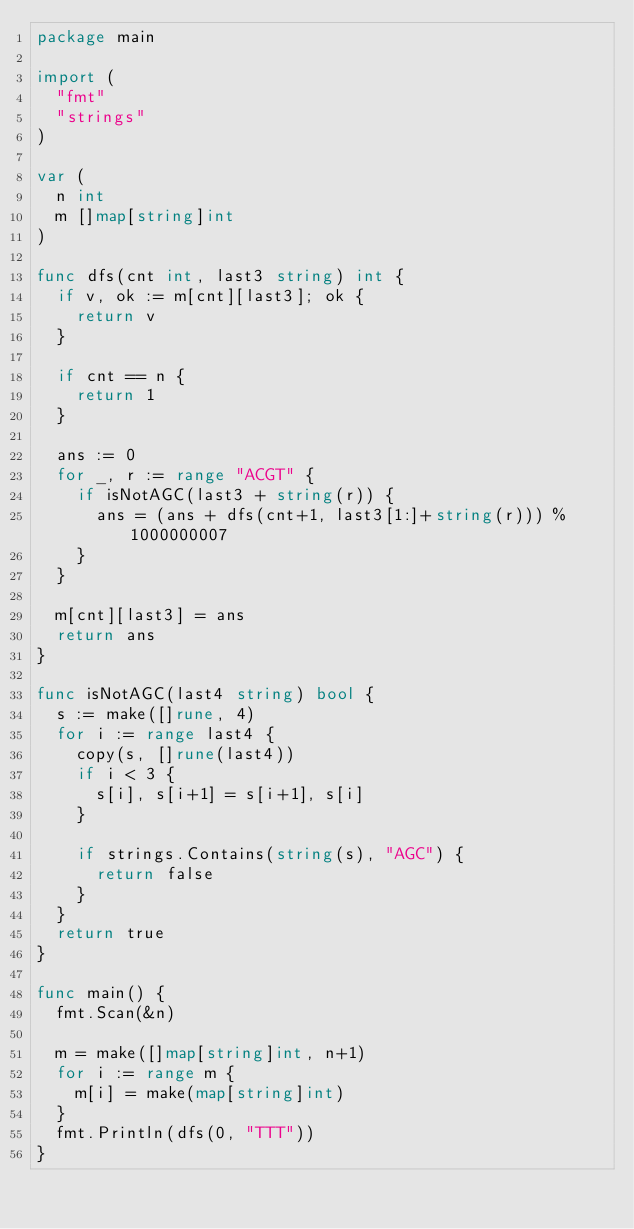<code> <loc_0><loc_0><loc_500><loc_500><_Go_>package main

import (
	"fmt"
	"strings"
)

var (
	n int
	m []map[string]int
)

func dfs(cnt int, last3 string) int {
	if v, ok := m[cnt][last3]; ok {
		return v
	}

	if cnt == n {
		return 1
	}

	ans := 0
	for _, r := range "ACGT" {
		if isNotAGC(last3 + string(r)) {
			ans = (ans + dfs(cnt+1, last3[1:]+string(r))) % 1000000007
		}
	}

	m[cnt][last3] = ans
	return ans
}

func isNotAGC(last4 string) bool {
	s := make([]rune, 4)
	for i := range last4 {
		copy(s, []rune(last4))
		if i < 3 {
			s[i], s[i+1] = s[i+1], s[i]
		}

		if strings.Contains(string(s), "AGC") {
			return false
		}
	}
	return true
}

func main() {
	fmt.Scan(&n)

	m = make([]map[string]int, n+1)
	for i := range m {
		m[i] = make(map[string]int)
	}
	fmt.Println(dfs(0, "TTT"))
}
</code> 